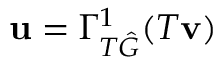<formula> <loc_0><loc_0><loc_500><loc_500>u = \Gamma _ { T \hat { G } } ^ { 1 } ( T v )</formula> 